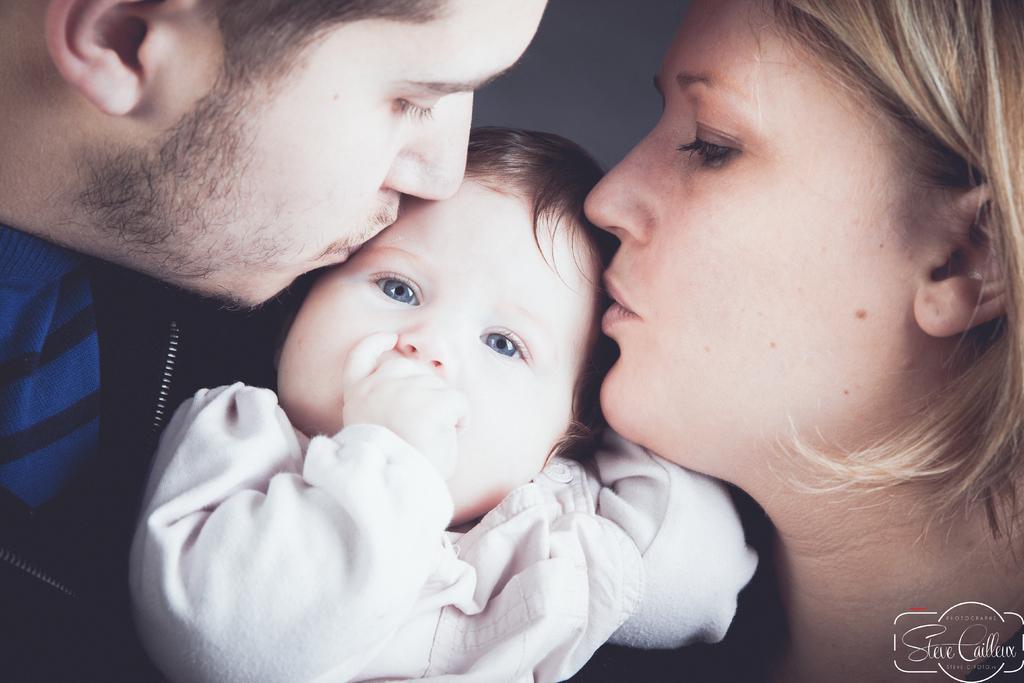Can you describe this image briefly? In this image, we can see a man and woman are kissing a baby together. Background we can see white color. Right side bottom corner, we can see a watermark in the image. 